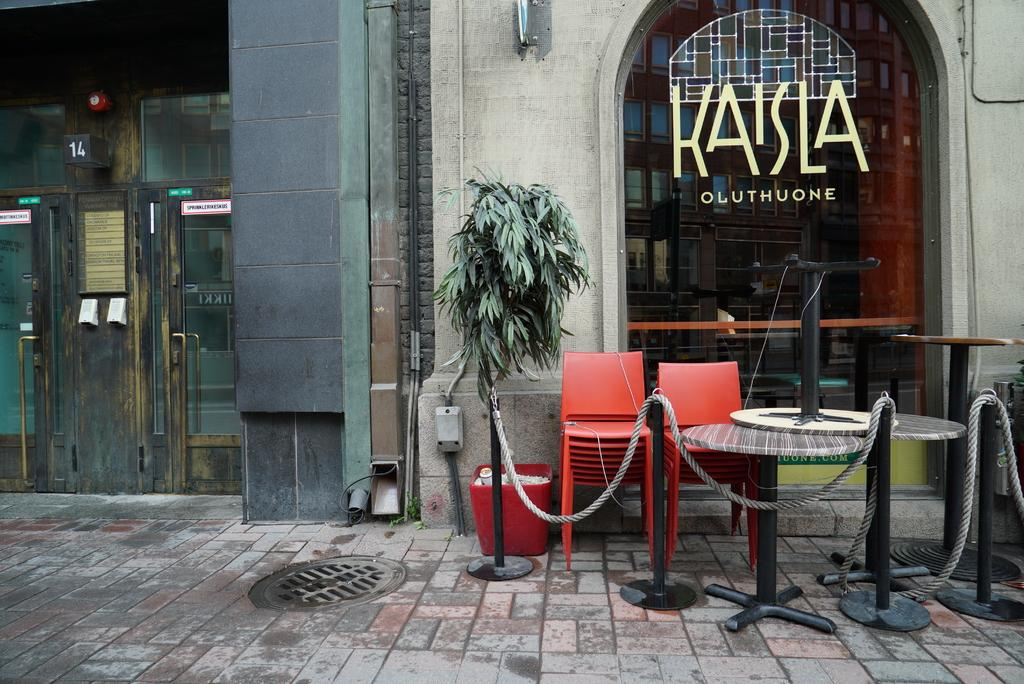What type of fence is visible in the image? There is a rope fence in the image. What type of seating is available in the image? There are sitting chairs in the image. Where are the tables located in the image? The tables are on the right side of the image. What is located on the left side of the image? There is a door on the left side of the image. What type of window is present on the right side of the image? There is a glass window on the right side of the image. How many jellyfish are swimming in the image? There are no jellyfish present in the image. What type of servant is attending to the guests in the image? There is no servant present in the image. 